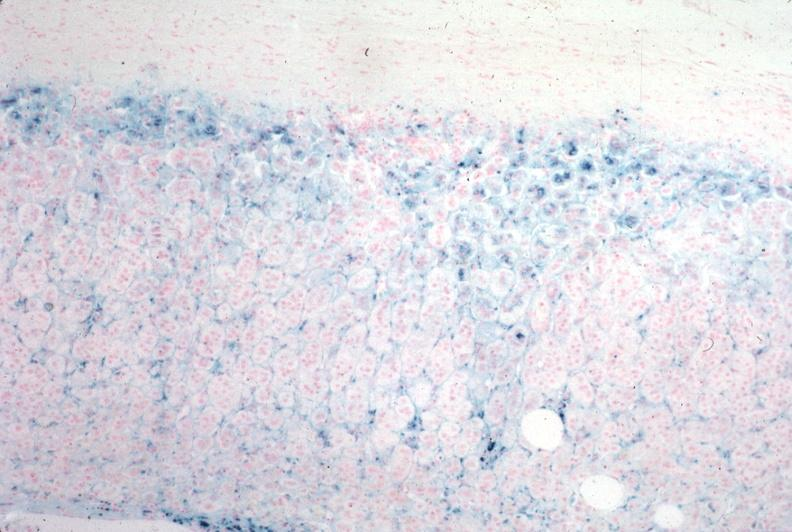s hemochromatosis present?
Answer the question using a single word or phrase. Yes 